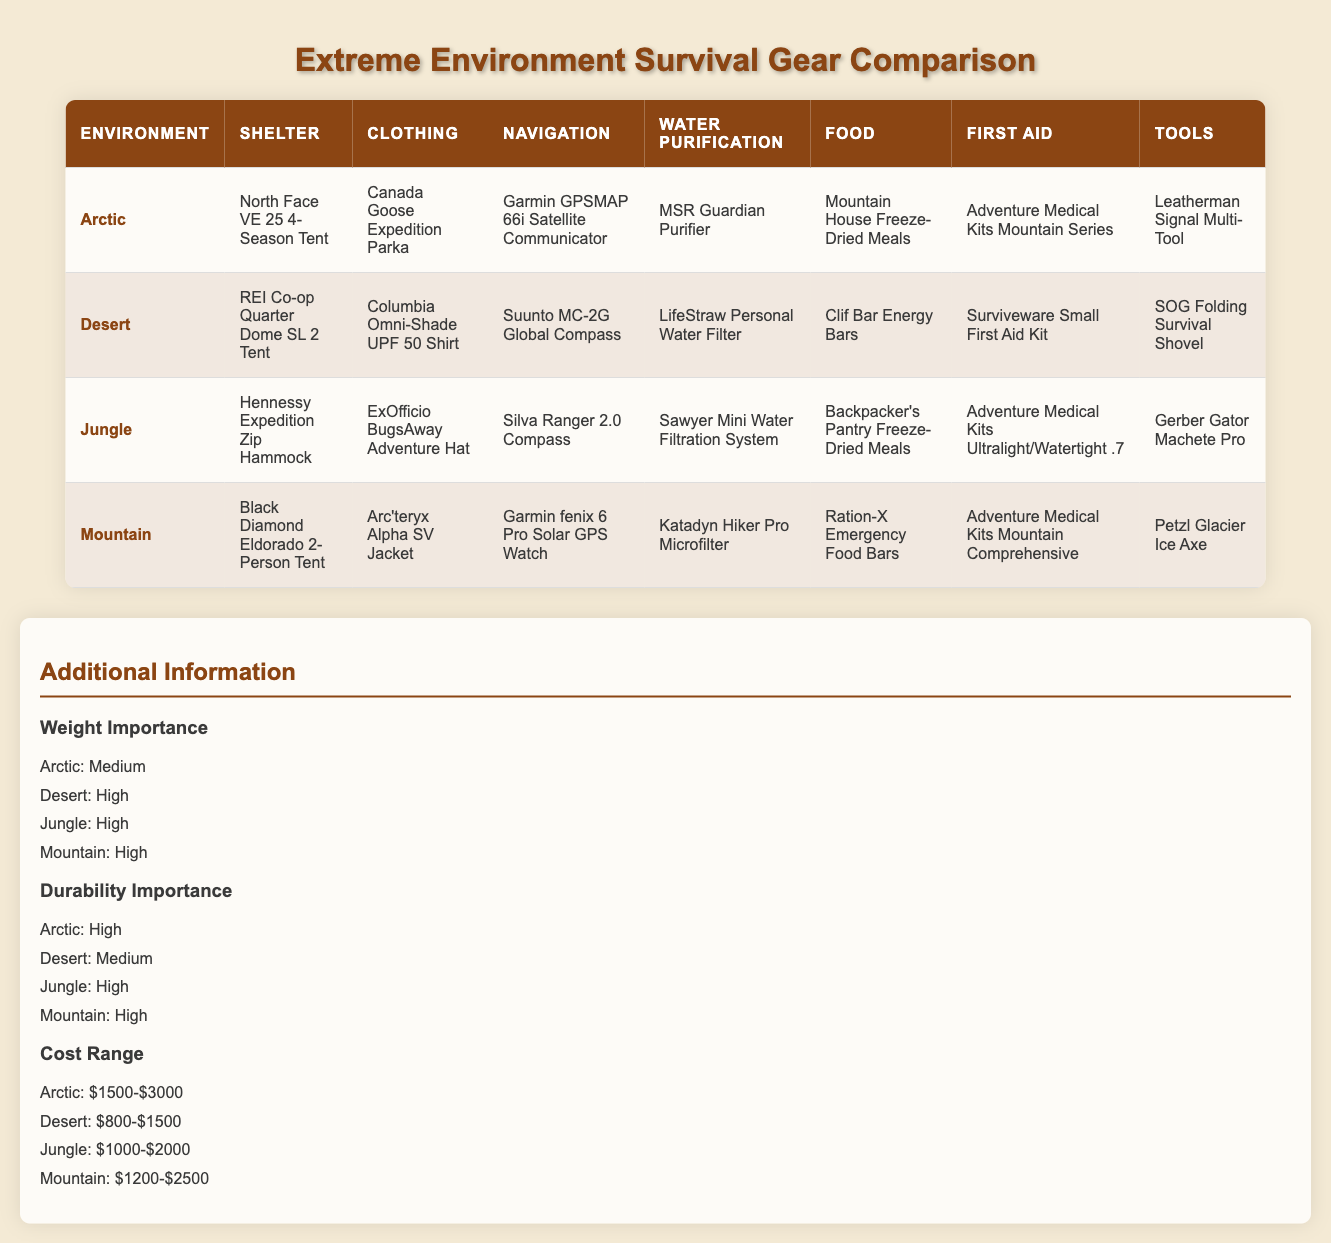What type of shelter is recommended for the Jungle environment? In the 'Jungle' row of the table, the 'Shelter' category lists the recommended shelter as "Hennessy Expedition Zip Hammock."
Answer: Hennessy Expedition Zip Hammock Which environment has the highest importance on weight? By looking at the 'Weight Importance' additional information section, the 'Desert', 'Jungle', and 'Mountain' environments are all noted as having 'High' weight importance, while 'Arctic' is 'Medium'. Since multiple environments are tied for the highest, it’s appropriate to acknowledge all.
Answer: Desert, Jungle, Mountain What is the cost range for survival gear in the Arctic environment? Referring to the 'Cost Range' additional information, it indicates the Arctic has a cost range of "$1500-$3000".
Answer: $1500-$3000 Is the Garmin GPSMAP 66i Satellite Communicator used for Desert navigation? The table specifies that the 'Navigation' gear for the Desert environment is "Suunto MC-2G Global Compass." Since this is different from the Garmin device, the answer is no.
Answer: No Compare the first aid kits between the Mountain and Desert environments. In the table, the 'First Aid' gear for Mountain is "Adventure Medical Kits Mountain Comprehensive," while for Desert, it is "Surviveware Small First Aid Kit." Comparing both indicates that Mountain has a more comprehensive option. Specifically, Mountain’s kit is designed for more severe injuries typical in mountainous areas, while Desert’s kit is smaller and more portable, suitable for less critical situations.
Answer: Mountain kit is more comprehensive What is the average cost range of survival gear across the four environments? The cost ranges for each environment are: Arctic ($1500-$3000), Desert ($800-$1500), Jungle ($1000-$2000), and Mountain ($1200-$2500). To find an average, we consider the midpoints: Arctic ($2250), Desert ($1150), Jungle ($1500), Mountain ($1850). Adding these values gives $2250 + $1150 + $1500 + $1850 = $6750, and dividing by 4 gives an average of $1687.50.
Answer: $1687.50 Which environment has the same level of durability importance as Jungle? Looking at the 'Durability Importance' section, we see 'Arctic' and 'Mountain' are marked 'High', just like 'Jungle'. Therefore, the environments that share this durability level with Jungle are Arctic and Mountain.
Answer: Arctic, Mountain 